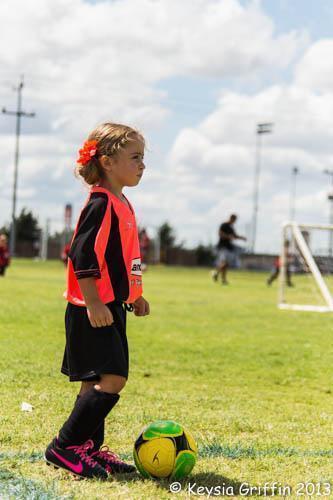What kind of poles stand erect in the background?
From the following set of four choices, select the accurate answer to respond to the question.
Options: Telephone, wind, electric, solar. Electric. 